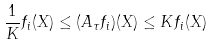Convert formula to latex. <formula><loc_0><loc_0><loc_500><loc_500>\frac { 1 } { K } f _ { i } ( X ) \leq ( A _ { \tau } f _ { i } ) ( X ) \leq K f _ { i } ( X )</formula> 